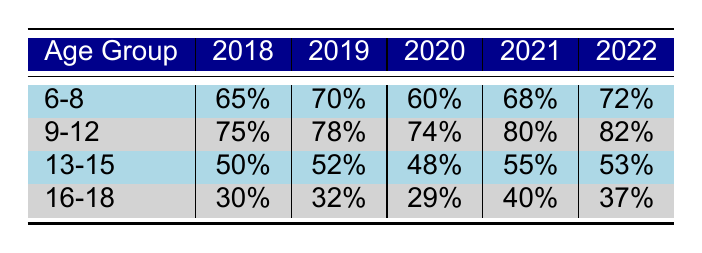What was the participation rate for the 9-12 age group in 2021? From the table, we can look at the row for the 9-12 age group and find the column for the year 2021. The participation rate listed there is 80%.
Answer: 80% Which age group had the highest participation rate in 2019? In 2019, we examine the participation rates for all age groups. The 9-12 age group shows a participation rate of 78%, which is the highest compared to the other age groups (6-8 at 70%, 13-15 at 52%, and 16-18 at 32%).
Answer: 9-12 What is the average participation rate for the 6-8 age group over the five years? To calculate the average, we sum the participation rates for the 6-8 age group: (65 + 70 + 60 + 68 + 72) = 335. There are 5 years, so the average participation rate is 335 / 5 = 67.
Answer: 67 Did the participation rate for the 13-15 age group increase from 2018 to 2021? In 2018, the participation rate for the 13-15 age group was 50%. By 2021, the rate increased to 55%. Since 55% is greater than 50%, we can conclude that there was an increase.
Answer: Yes Which age group had the lowest participation rate across all years? We compare the lowest participation rates for each age group over the five years. The 16-18 age group had rates of 30%, 32%, 29%, 40%, and 37%. The lowest rate overall is 29%, which is from 2020 for the 16-18 age group.
Answer: 16-18 